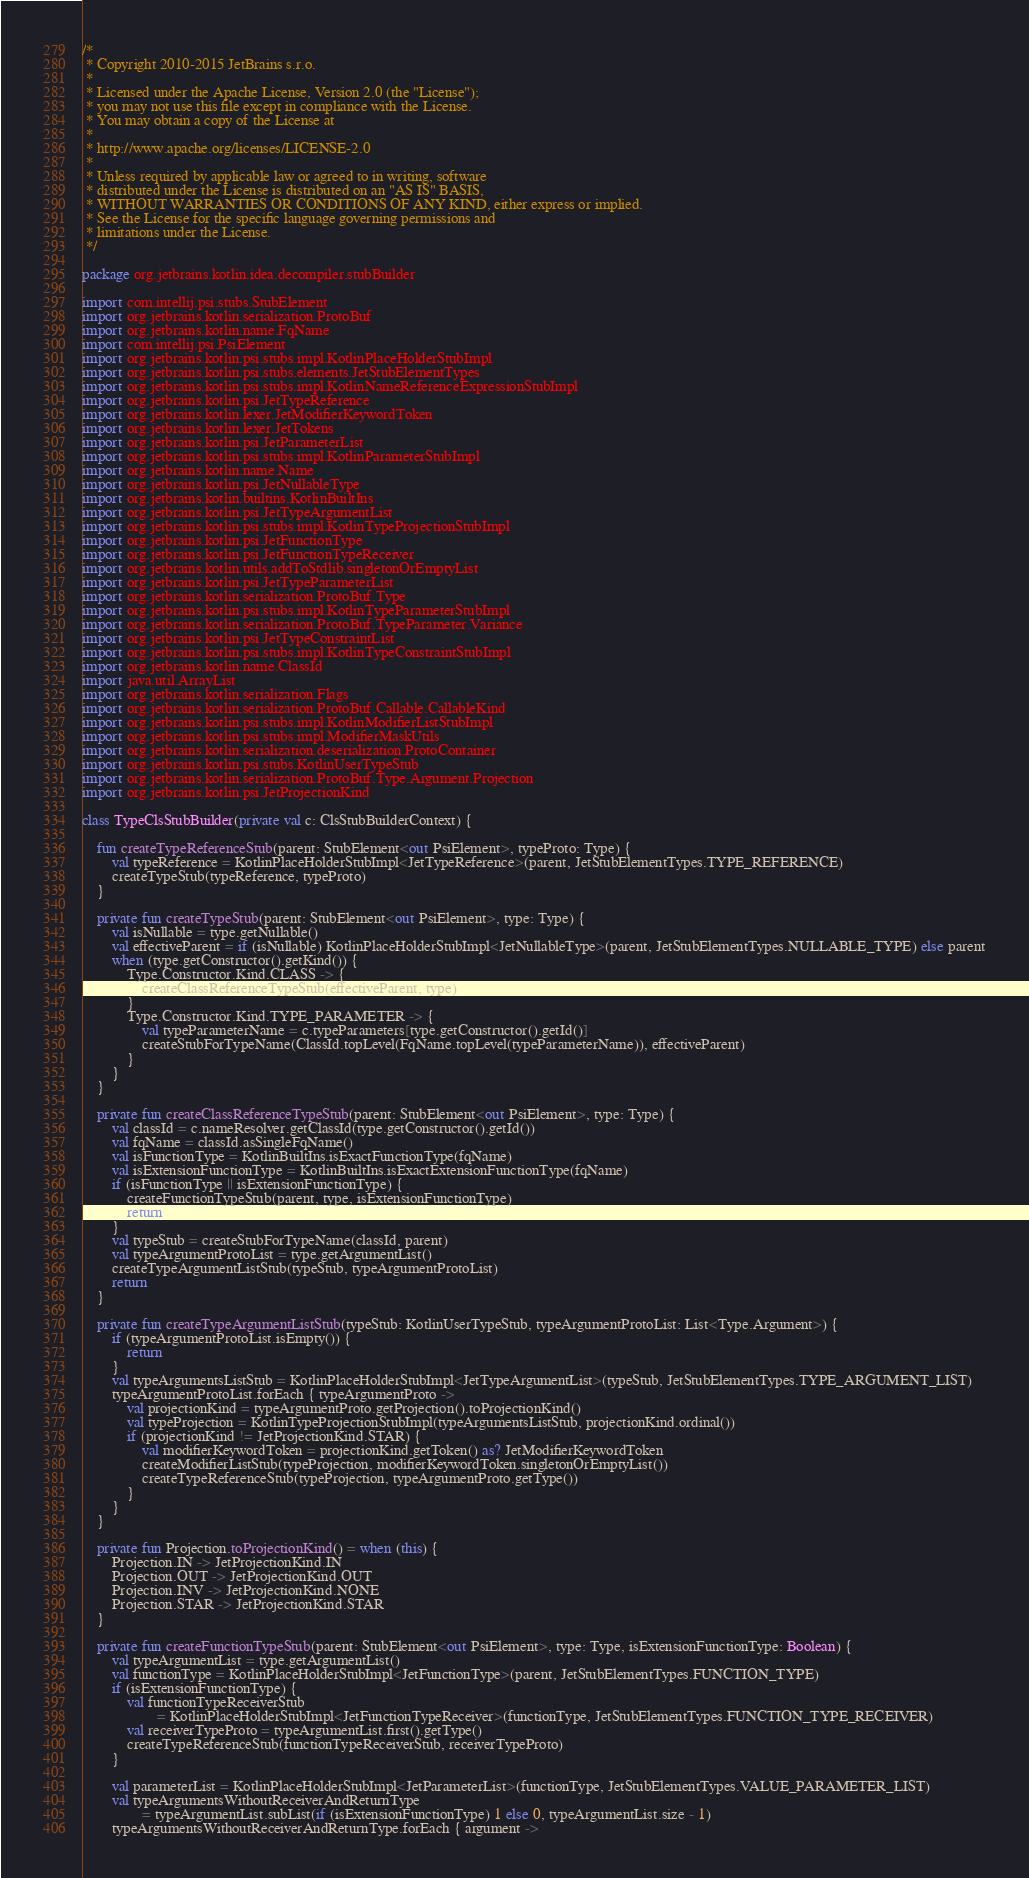<code> <loc_0><loc_0><loc_500><loc_500><_Kotlin_>/*
 * Copyright 2010-2015 JetBrains s.r.o.
 *
 * Licensed under the Apache License, Version 2.0 (the "License");
 * you may not use this file except in compliance with the License.
 * You may obtain a copy of the License at
 *
 * http://www.apache.org/licenses/LICENSE-2.0
 *
 * Unless required by applicable law or agreed to in writing, software
 * distributed under the License is distributed on an "AS IS" BASIS,
 * WITHOUT WARRANTIES OR CONDITIONS OF ANY KIND, either express or implied.
 * See the License for the specific language governing permissions and
 * limitations under the License.
 */

package org.jetbrains.kotlin.idea.decompiler.stubBuilder

import com.intellij.psi.stubs.StubElement
import org.jetbrains.kotlin.serialization.ProtoBuf
import org.jetbrains.kotlin.name.FqName
import com.intellij.psi.PsiElement
import org.jetbrains.kotlin.psi.stubs.impl.KotlinPlaceHolderStubImpl
import org.jetbrains.kotlin.psi.stubs.elements.JetStubElementTypes
import org.jetbrains.kotlin.psi.stubs.impl.KotlinNameReferenceExpressionStubImpl
import org.jetbrains.kotlin.psi.JetTypeReference
import org.jetbrains.kotlin.lexer.JetModifierKeywordToken
import org.jetbrains.kotlin.lexer.JetTokens
import org.jetbrains.kotlin.psi.JetParameterList
import org.jetbrains.kotlin.psi.stubs.impl.KotlinParameterStubImpl
import org.jetbrains.kotlin.name.Name
import org.jetbrains.kotlin.psi.JetNullableType
import org.jetbrains.kotlin.builtins.KotlinBuiltIns
import org.jetbrains.kotlin.psi.JetTypeArgumentList
import org.jetbrains.kotlin.psi.stubs.impl.KotlinTypeProjectionStubImpl
import org.jetbrains.kotlin.psi.JetFunctionType
import org.jetbrains.kotlin.psi.JetFunctionTypeReceiver
import org.jetbrains.kotlin.utils.addToStdlib.singletonOrEmptyList
import org.jetbrains.kotlin.psi.JetTypeParameterList
import org.jetbrains.kotlin.serialization.ProtoBuf.Type
import org.jetbrains.kotlin.psi.stubs.impl.KotlinTypeParameterStubImpl
import org.jetbrains.kotlin.serialization.ProtoBuf.TypeParameter.Variance
import org.jetbrains.kotlin.psi.JetTypeConstraintList
import org.jetbrains.kotlin.psi.stubs.impl.KotlinTypeConstraintStubImpl
import org.jetbrains.kotlin.name.ClassId
import java.util.ArrayList
import org.jetbrains.kotlin.serialization.Flags
import org.jetbrains.kotlin.serialization.ProtoBuf.Callable.CallableKind
import org.jetbrains.kotlin.psi.stubs.impl.KotlinModifierListStubImpl
import org.jetbrains.kotlin.psi.stubs.impl.ModifierMaskUtils
import org.jetbrains.kotlin.serialization.deserialization.ProtoContainer
import org.jetbrains.kotlin.psi.stubs.KotlinUserTypeStub
import org.jetbrains.kotlin.serialization.ProtoBuf.Type.Argument.Projection
import org.jetbrains.kotlin.psi.JetProjectionKind

class TypeClsStubBuilder(private val c: ClsStubBuilderContext) {

    fun createTypeReferenceStub(parent: StubElement<out PsiElement>, typeProto: Type) {
        val typeReference = KotlinPlaceHolderStubImpl<JetTypeReference>(parent, JetStubElementTypes.TYPE_REFERENCE)
        createTypeStub(typeReference, typeProto)
    }

    private fun createTypeStub(parent: StubElement<out PsiElement>, type: Type) {
        val isNullable = type.getNullable()
        val effectiveParent = if (isNullable) KotlinPlaceHolderStubImpl<JetNullableType>(parent, JetStubElementTypes.NULLABLE_TYPE) else parent
        when (type.getConstructor().getKind()) {
            Type.Constructor.Kind.CLASS -> {
                createClassReferenceTypeStub(effectiveParent, type)
            }
            Type.Constructor.Kind.TYPE_PARAMETER -> {
                val typeParameterName = c.typeParameters[type.getConstructor().getId()]
                createStubForTypeName(ClassId.topLevel(FqName.topLevel(typeParameterName)), effectiveParent)
            }
        }
    }

    private fun createClassReferenceTypeStub(parent: StubElement<out PsiElement>, type: Type) {
        val classId = c.nameResolver.getClassId(type.getConstructor().getId())
        val fqName = classId.asSingleFqName()
        val isFunctionType = KotlinBuiltIns.isExactFunctionType(fqName)
        val isExtensionFunctionType = KotlinBuiltIns.isExactExtensionFunctionType(fqName)
        if (isFunctionType || isExtensionFunctionType) {
            createFunctionTypeStub(parent, type, isExtensionFunctionType)
            return
        }
        val typeStub = createStubForTypeName(classId, parent)
        val typeArgumentProtoList = type.getArgumentList()
        createTypeArgumentListStub(typeStub, typeArgumentProtoList)
        return
    }

    private fun createTypeArgumentListStub(typeStub: KotlinUserTypeStub, typeArgumentProtoList: List<Type.Argument>) {
        if (typeArgumentProtoList.isEmpty()) {
            return
        }
        val typeArgumentsListStub = KotlinPlaceHolderStubImpl<JetTypeArgumentList>(typeStub, JetStubElementTypes.TYPE_ARGUMENT_LIST)
        typeArgumentProtoList.forEach { typeArgumentProto ->
            val projectionKind = typeArgumentProto.getProjection().toProjectionKind()
            val typeProjection = KotlinTypeProjectionStubImpl(typeArgumentsListStub, projectionKind.ordinal())
            if (projectionKind != JetProjectionKind.STAR) {
                val modifierKeywordToken = projectionKind.getToken() as? JetModifierKeywordToken
                createModifierListStub(typeProjection, modifierKeywordToken.singletonOrEmptyList())
                createTypeReferenceStub(typeProjection, typeArgumentProto.getType())
            }
        }
    }

    private fun Projection.toProjectionKind() = when (this) {
        Projection.IN -> JetProjectionKind.IN
        Projection.OUT -> JetProjectionKind.OUT
        Projection.INV -> JetProjectionKind.NONE
        Projection.STAR -> JetProjectionKind.STAR
    }

    private fun createFunctionTypeStub(parent: StubElement<out PsiElement>, type: Type, isExtensionFunctionType: Boolean) {
        val typeArgumentList = type.getArgumentList()
        val functionType = KotlinPlaceHolderStubImpl<JetFunctionType>(parent, JetStubElementTypes.FUNCTION_TYPE)
        if (isExtensionFunctionType) {
            val functionTypeReceiverStub
                    = KotlinPlaceHolderStubImpl<JetFunctionTypeReceiver>(functionType, JetStubElementTypes.FUNCTION_TYPE_RECEIVER)
            val receiverTypeProto = typeArgumentList.first().getType()
            createTypeReferenceStub(functionTypeReceiverStub, receiverTypeProto)
        }

        val parameterList = KotlinPlaceHolderStubImpl<JetParameterList>(functionType, JetStubElementTypes.VALUE_PARAMETER_LIST)
        val typeArgumentsWithoutReceiverAndReturnType
                = typeArgumentList.subList(if (isExtensionFunctionType) 1 else 0, typeArgumentList.size - 1)
        typeArgumentsWithoutReceiverAndReturnType.forEach { argument -></code> 